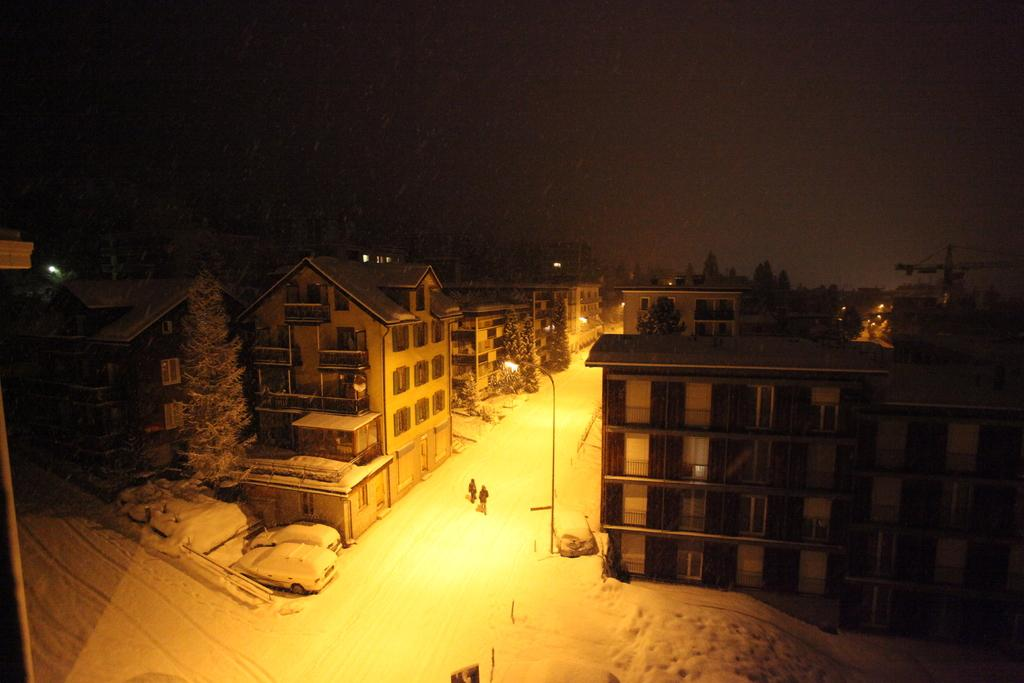What type of structures are present in the image? There are buildings in the image. What can be seen on the buildings in the image? There are windows visible in the image. What type of vegetation is present in the image? There are trees in the image. What type of lighting is present in the image? There are light poles in the image. Are there any living beings in the image? Yes, there are people in the image. What is the weather like in the image? There is snow in the image, indicating a cold and likely wintery scene. What is the color of the background in the image? The background of the image is dark. What type of advertisement can be seen on the library in the image? There is no library or advertisement present in the image. What type of insect is crawling on the snow in the image? There are no insects visible in the image; it is a scene with buildings, trees, light poles, people, and snow. 